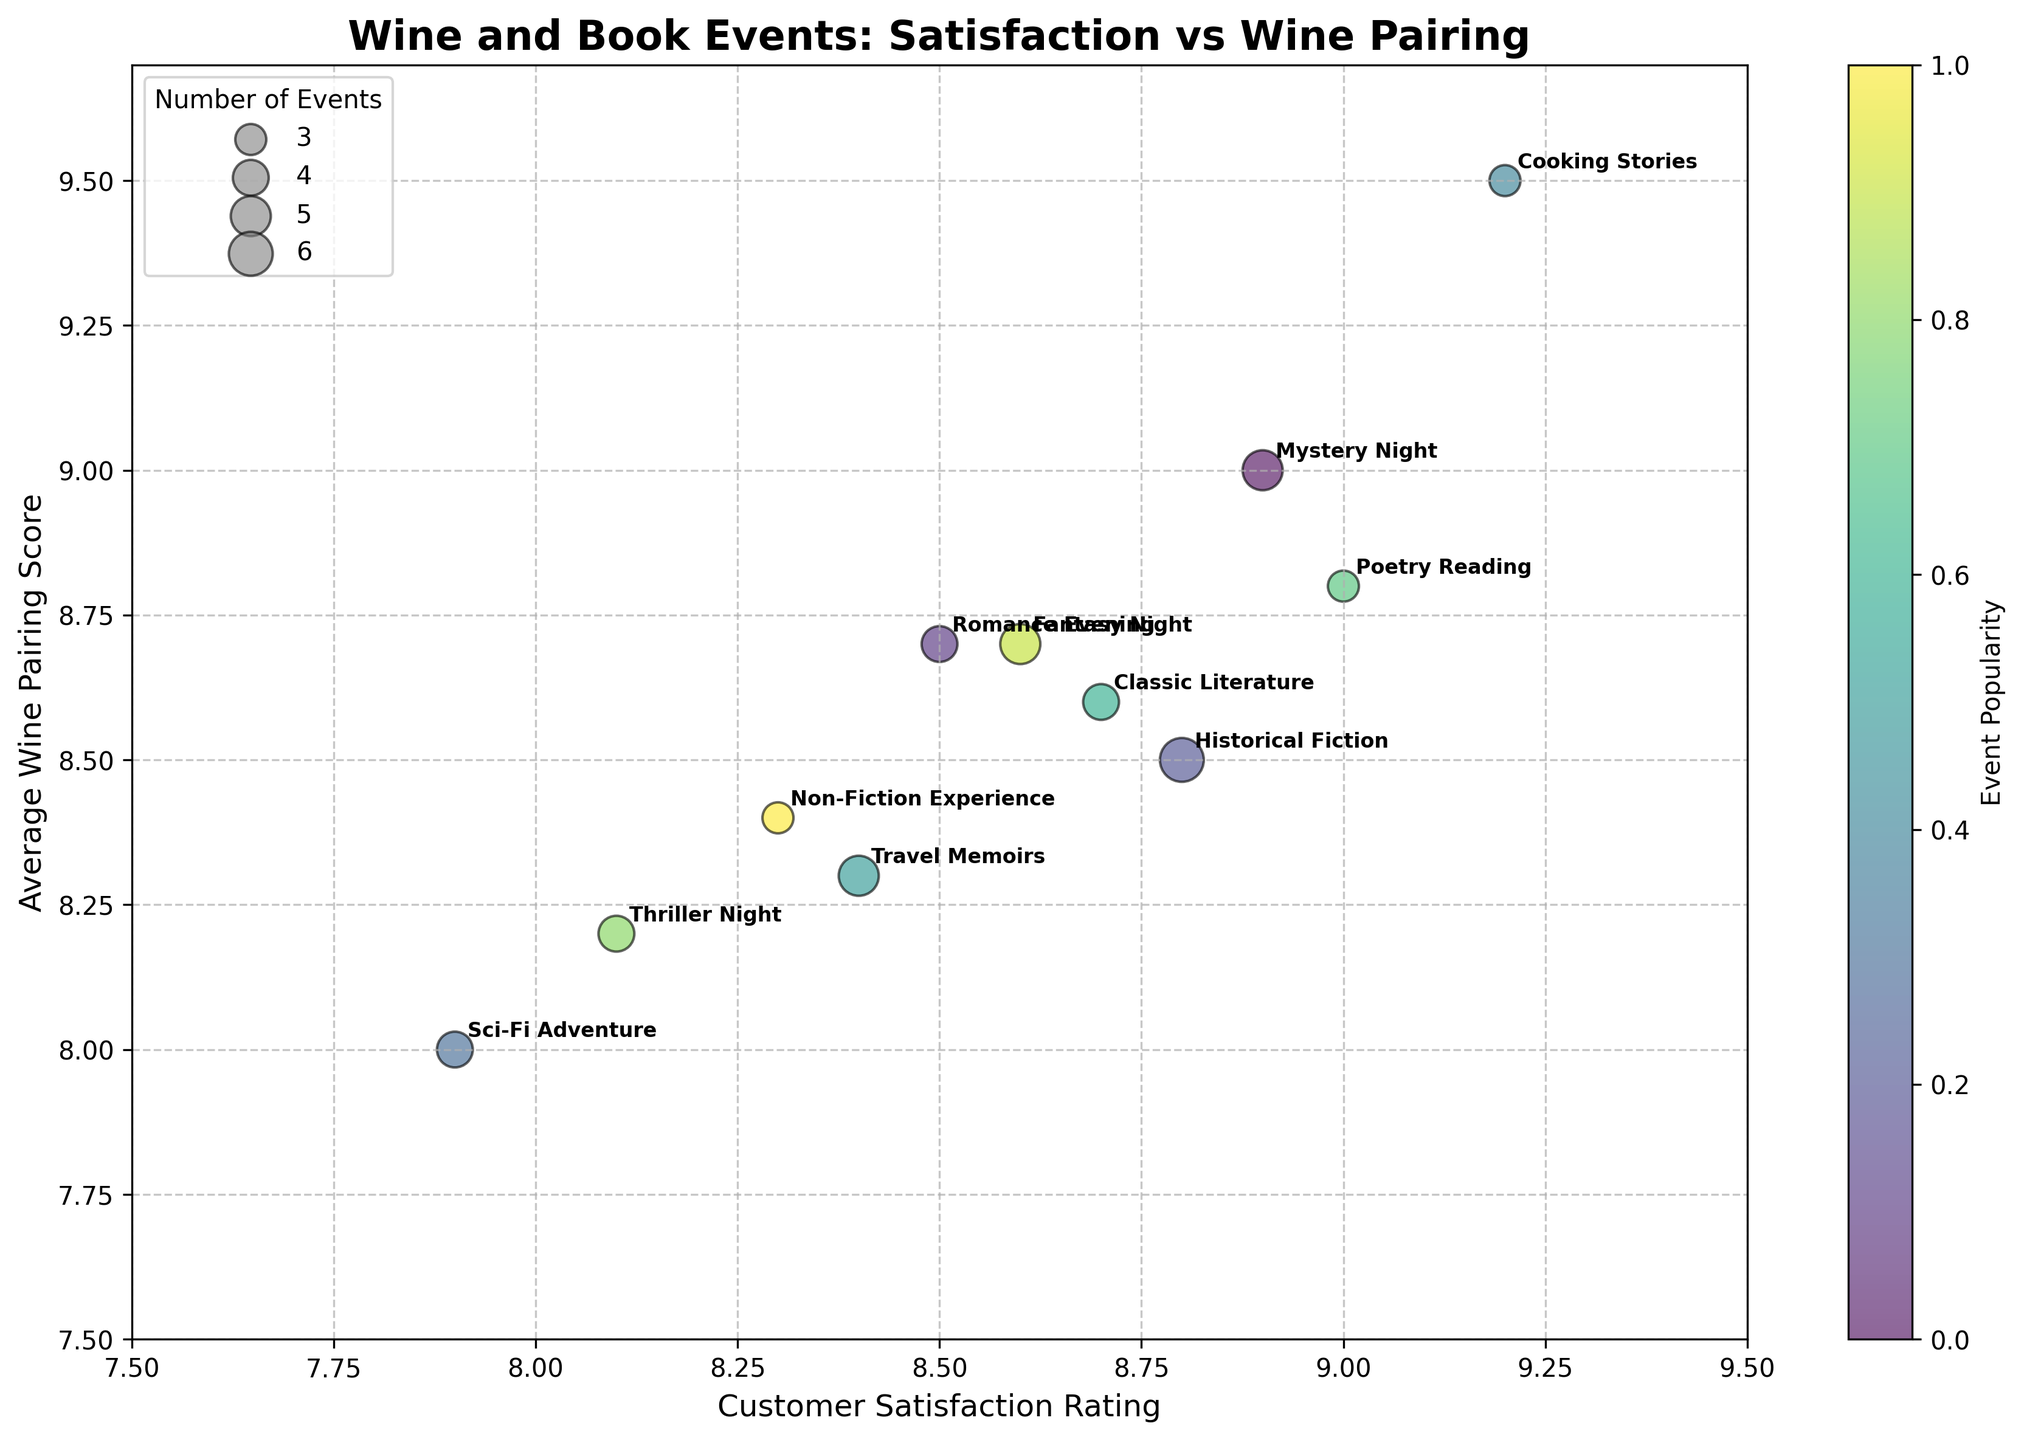How many event themes were plotted in the bubble chart? Count the labels (events) represented by the bubbles in the chart. The number of unique labels corresponds to the number of event themes.
Answer: 11 What are the axes labels of the chart? Read the description provided along the x-axis and y-axis of the chart.
Answer: Customer Satisfaction Rating (x-axis) and Average Wine Pairing Score (y-axis) Which event theme has the highest average wine pairing score? Look for the highest point on the y-axis and check the label associated with that bubble.
Answer: Cooking Stories What is the size of the bubble for Fantasy Night representing the number of events? Look at the size of the bubble labeled "Fantasy Night" and infer the number from the legend.
Answer: 5 Which event theme has the lowest customer satisfaction rating? Look for the leftmost point on the x-axis and check the label associated with that bubble.
Answer: Sci-Fi Adventure How does the customer satisfaction rating for Poetry Reading compare to Travel Memoirs? Check the positions of the bubbles for Poetry Reading and Travel Memoirs on the x-axis and compare their values.
Answer: Poetry Reading is higher Which two event themes have bubbles with the same size and what is that event count? Identify two bubbles of the same size by comparing their visual sizes and confirm their event count from the legend.
Answer: Romance Evening and Classic Literature; both with 4 events What is the average customer satisfaction rating for events with 3 occurrences? Identify the bubbles corresponding to events with size 3, sum their x-axis values, and then divide by the number of such bubbles.
Answer: (9.2 + 9.0 + 8.3) / 3 = 8.83 Which event theme shows a higher satisfaction rating: Mystery Night or Non-Fiction Experience? Compare the x-axis positions of the bubbles for Mystery Night and Non-Fiction Experience.
Answer: Mystery Night 